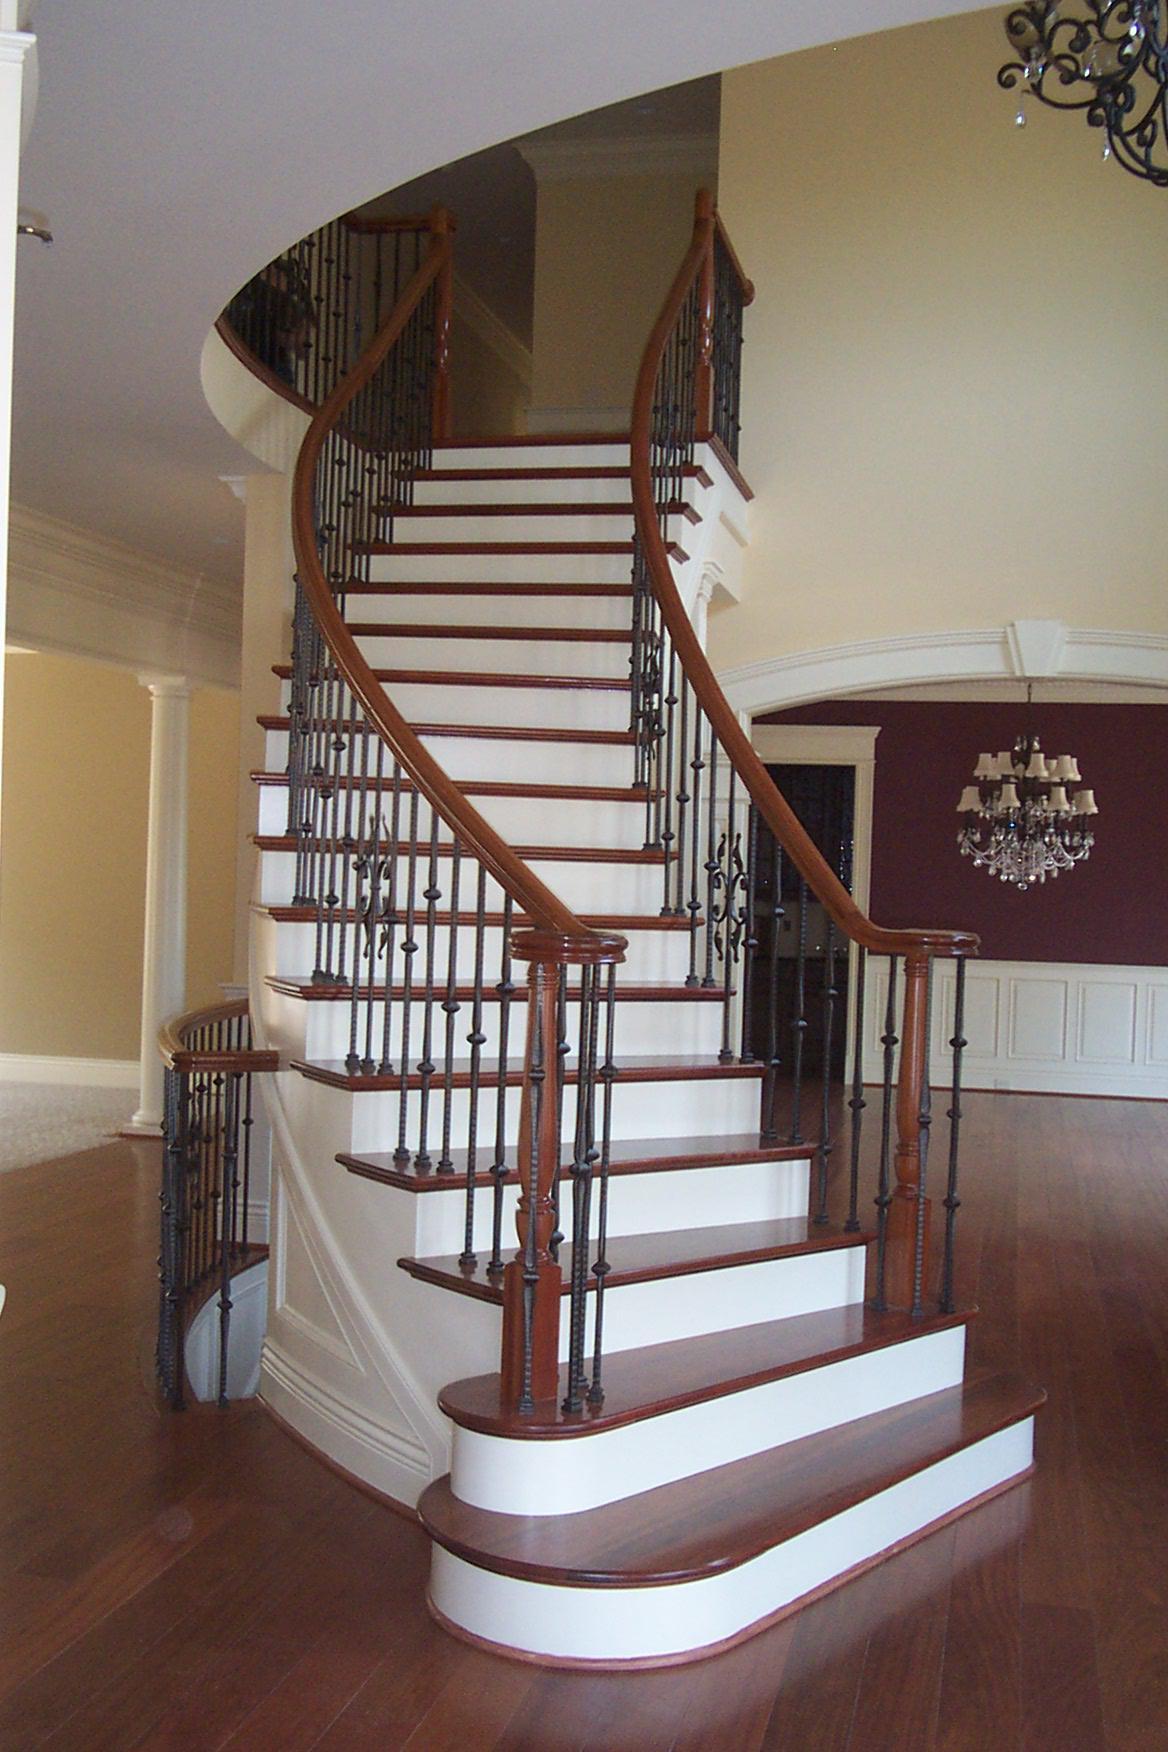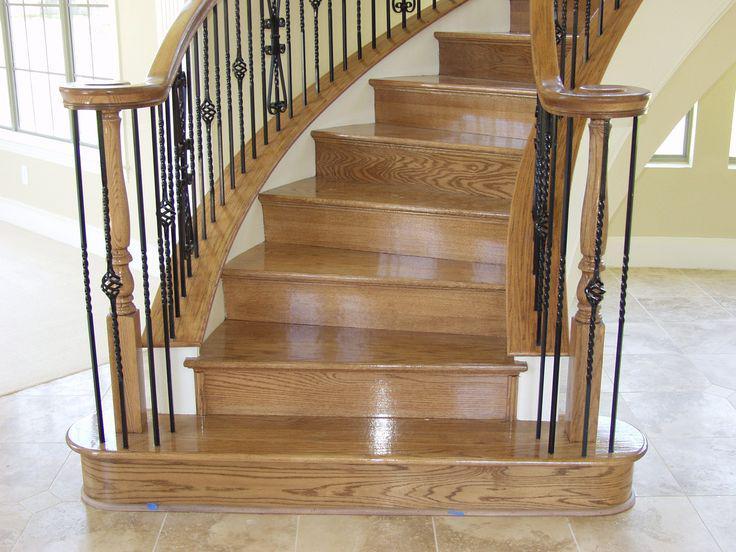The first image is the image on the left, the second image is the image on the right. Considering the images on both sides, is "The left staircase is straight and the right staircase is curved." valid? Answer yes or no. No. The first image is the image on the left, the second image is the image on the right. Assess this claim about the two images: "One of the images shows a straight staircase and the other shows a curved staircase.". Correct or not? Answer yes or no. No. 